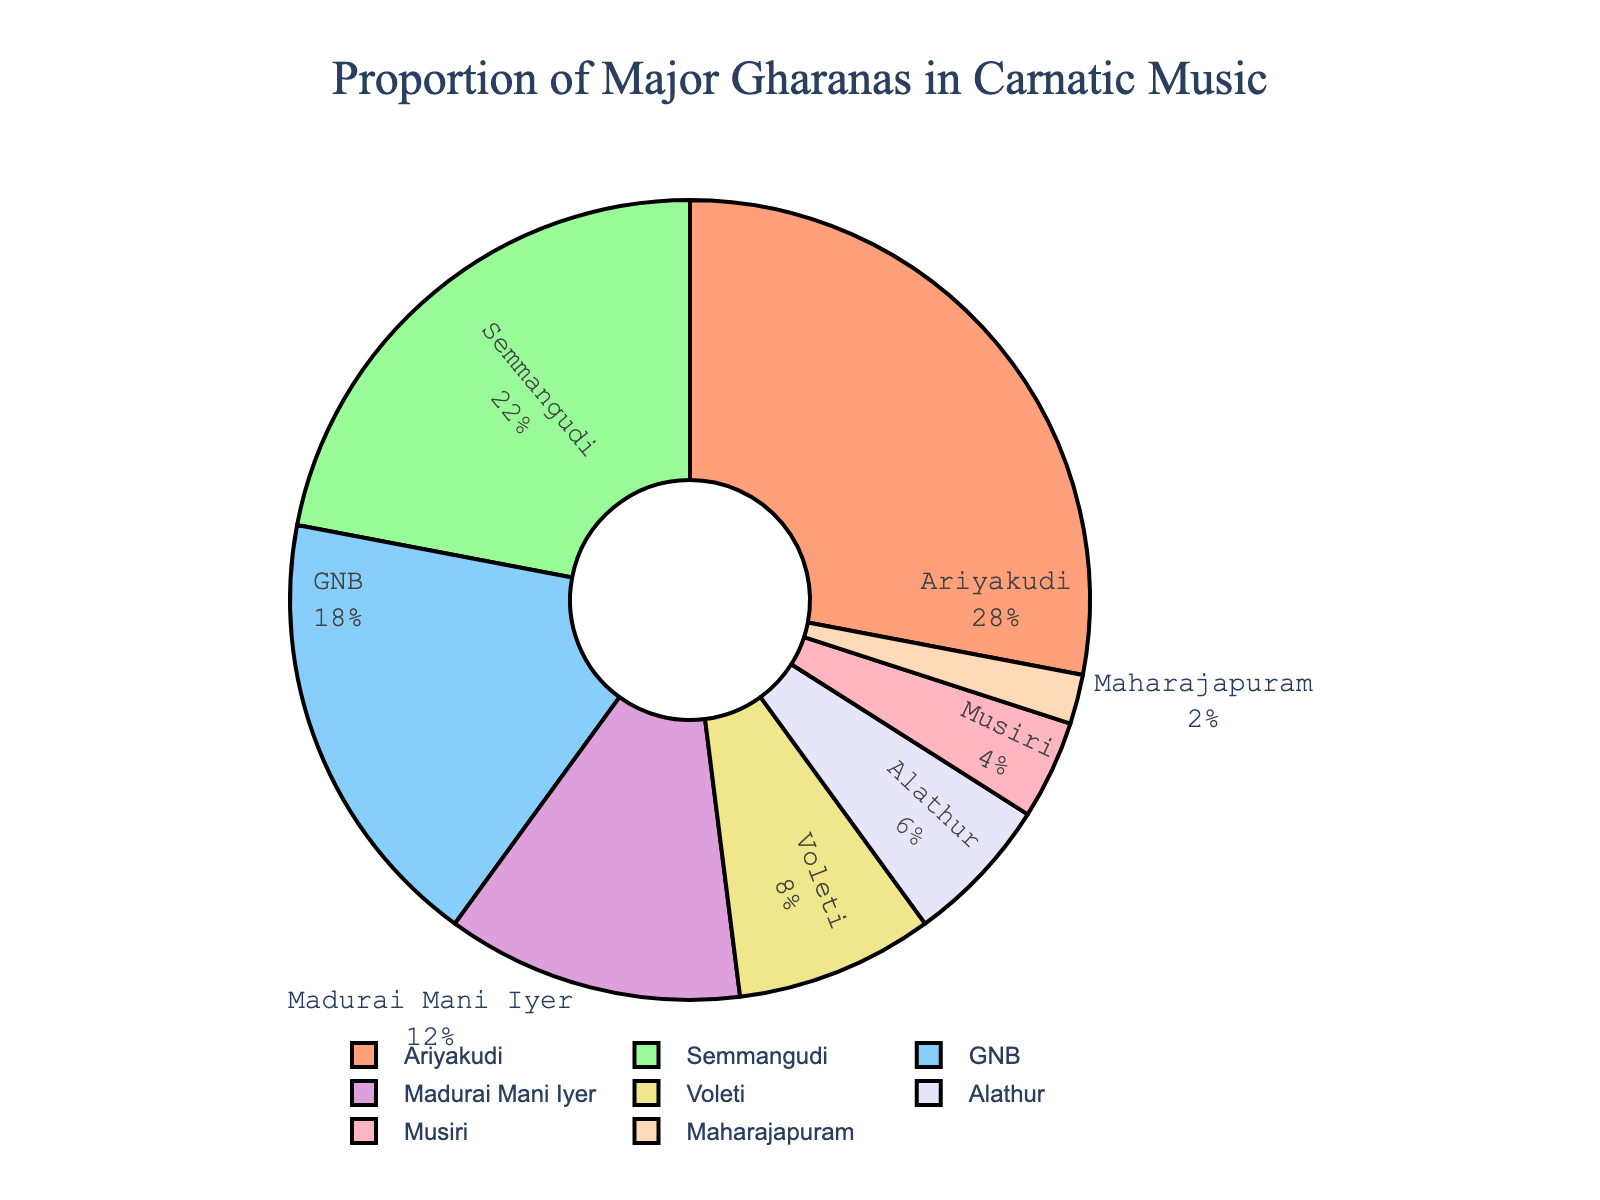What proportion of the chart does the Ariyakudi gharana occupy? To determine the proportion, look at the section labeled "Ariyakudi" and the percentage annotated. It shows that the Ariyakudi gharana occupies 28% of the chart.
Answer: 28% Which two gharanas together form 50% of the chart? Adding the percentages of Ariyakudi (28%) and Semmangudi (22%) gives a total of 28% + 22% = 50%.
Answer: Ariyakudi and Semmangudi How much larger is the GNB gharana compared to the Maharajapuram gharana? Subtract the percentage of the Maharajapuram gharana (2%) from the percentage of the GNB gharana (18%). 18% - 2% = 16%.
Answer: 16% Which gharana has the smallest proportion in the chart? Identify the smallest percentage in the chart, which is associated with the Maharajapuram gharana at 2%.
Answer: Maharajapuram What is the combined percentage of the three largest gharanas? Add the percentages of the three largest gharanas: Ariyakudi (28%), Semmangudi (22%), and GNB (18%). 28% + 22% + 18% = 68%.
Answer: 68% How does the percentage of Voleti compare to that of Alathur? The Voleti gharana accounts for 8% while the Alathur gharana accounts for 6%. To compare, subtract 6% from 8%: 8% - 6% = 2%. Voleti is 2% larger than Alathur.
Answer: Voleti is 2% larger What proportion of the chart is occupied by gharanas other than Ariyakudi and Semmangudi? First, find the sum of the percentages of Ariyakudi and Semmangudi: 28% + 22% = 50%. Then, subtract this from 100%: 100% - 50% = 50%.
Answer: 50% Which gharana segments are visually smaller than the Voleti segment? The percentages of Alathur (6%), Musiri (4%), and Maharajapuram (2%) are all smaller than the Voleti's percentage of 8%.
Answer: Alathur, Musiri, and Maharajapuram Which two gharanas have percentages that sum to the same as Madurai Mani Iyer's percentage? The two percentages that sum up to Madurai Mani Iyer's percentage (12%) are Alathur (6%) and Musiri (4%). 6% + 4% = 10% is closest to 12% (since no two exact sum up to 12%).
Answer: Alathur and Musiri (approximated) In terms of visual representation, how is the hole at the center of the pie chart represented? The hole in the center is a design element called a "donut" hole, indicating that it is a donut chart rather than a solid pie chart. This provides a centered spacing visual effect.
Answer: Donut hole 